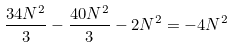<formula> <loc_0><loc_0><loc_500><loc_500>\frac { 3 4 N ^ { 2 } } { 3 } - \frac { 4 0 N ^ { 2 } } { 3 } - 2 N ^ { 2 } = - 4 N ^ { 2 }</formula> 